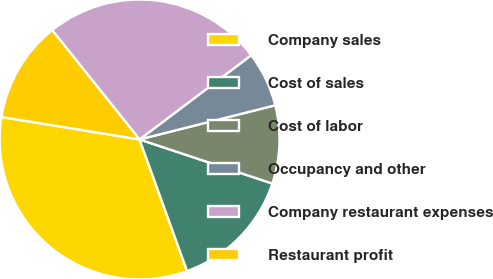Convert chart. <chart><loc_0><loc_0><loc_500><loc_500><pie_chart><fcel>Company sales<fcel>Cost of sales<fcel>Cost of labor<fcel>Occupancy and other<fcel>Company restaurant expenses<fcel>Restaurant profit<nl><fcel>33.08%<fcel>14.38%<fcel>9.03%<fcel>6.36%<fcel>25.45%<fcel>11.7%<nl></chart> 